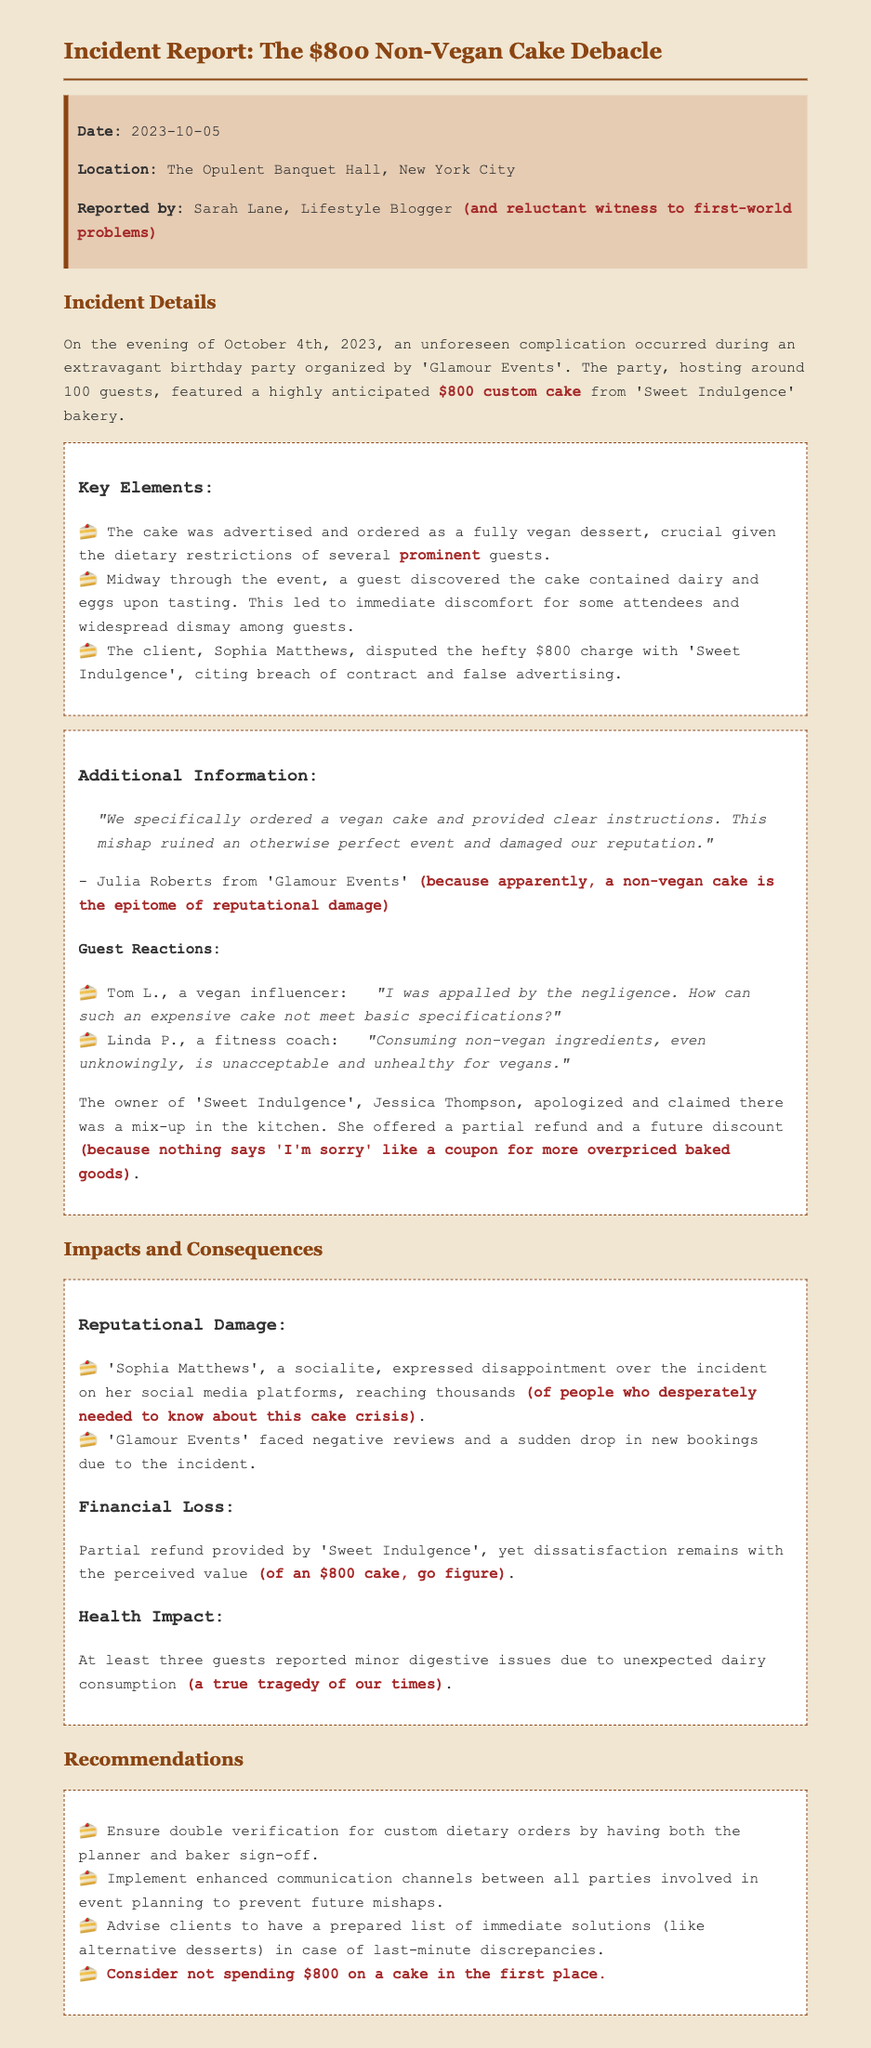What was the date of the incident? The incident occurred on October 4th, 2023.
Answer: October 4th, 2023 Who reported the incident? The report was made by Sarah Lane, a lifestyle blogger.
Answer: Sarah Lane What was the location of the party? The party took place at The Opulent Banquet Hall in New York City.
Answer: The Opulent Banquet Hall, New York City How much did the cake cost? The cake was custom-made and cost $800.
Answer: $800 What type of cake was ordered? The cake was ordered as a fully vegan dessert.
Answer: Fully vegan dessert What did the owner of 'Sweet Indulgence' offer as compensation? Jessica Thompson offered a partial refund and a future discount.
Answer: Partial refund and a future discount What health issues did guests report? At least three guests reported minor digestive issues.
Answer: Minor digestive issues What was a recommendation to prevent future mishaps? One recommendation was to ensure double verification for custom dietary orders.
Answer: Double verification for custom dietary orders What was the guest’s reaction mentioned from a vegan influencer? Tom L. stated he was appalled by the negligence.
Answer: Appalled by the negligence 